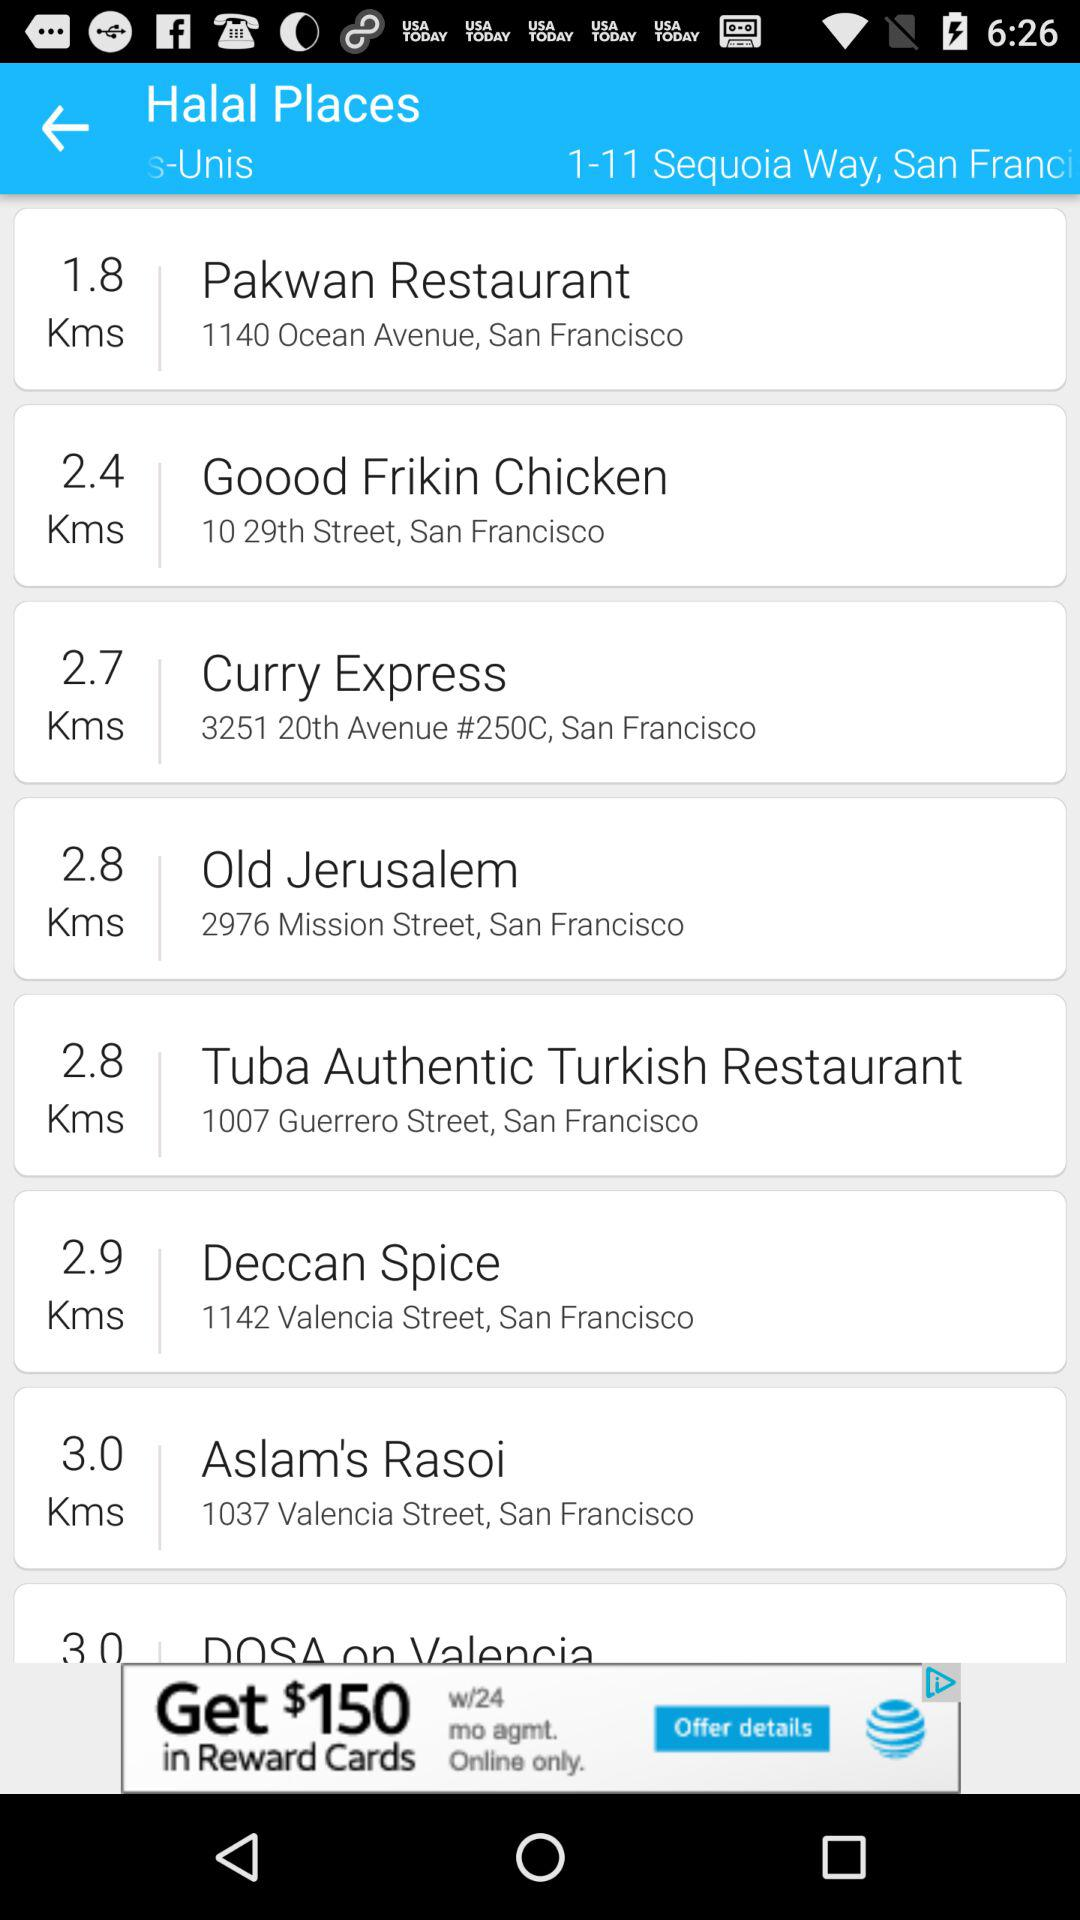What place is 2.7 km away from 1-11 Sequoia Way, San Francisco? The place that is 2.7 km away from 1-11 Sequoia Way, San Francisco is Curry Express. 